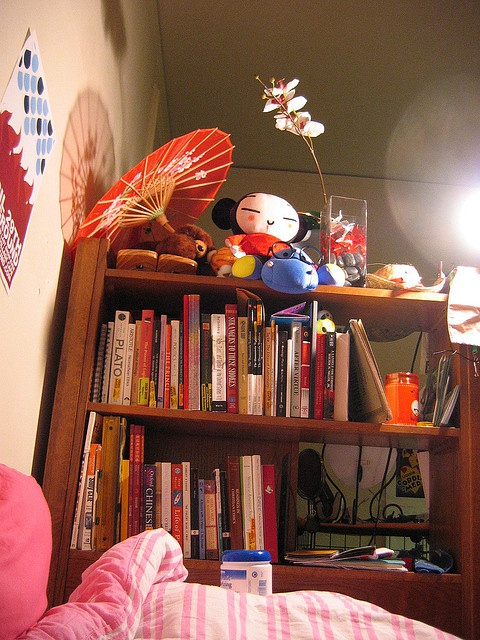Describe the objects in this image and their specific colors. I can see book in tan, black, maroon, and brown tones, bed in tan, pink, lightpink, salmon, and maroon tones, umbrella in tan, red, maroon, and brown tones, potted plant in tan, maroon, white, and brown tones, and book in tan and salmon tones in this image. 